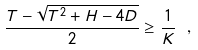Convert formula to latex. <formula><loc_0><loc_0><loc_500><loc_500>\frac { T - \sqrt { T ^ { 2 } + H - 4 D } } { 2 } \geq \frac { 1 } { K } \ ,</formula> 